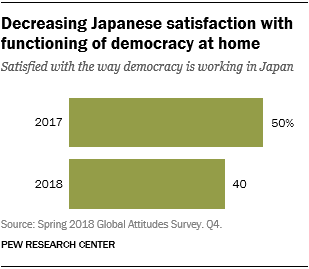Identify some key points in this picture. The difference between 2017 and 2018 in the percentage of Japanese satisfaction with democracy is 10%. In 2017, approximately half of the people in Japan were satisfied with the functioning of democracy in the country. 